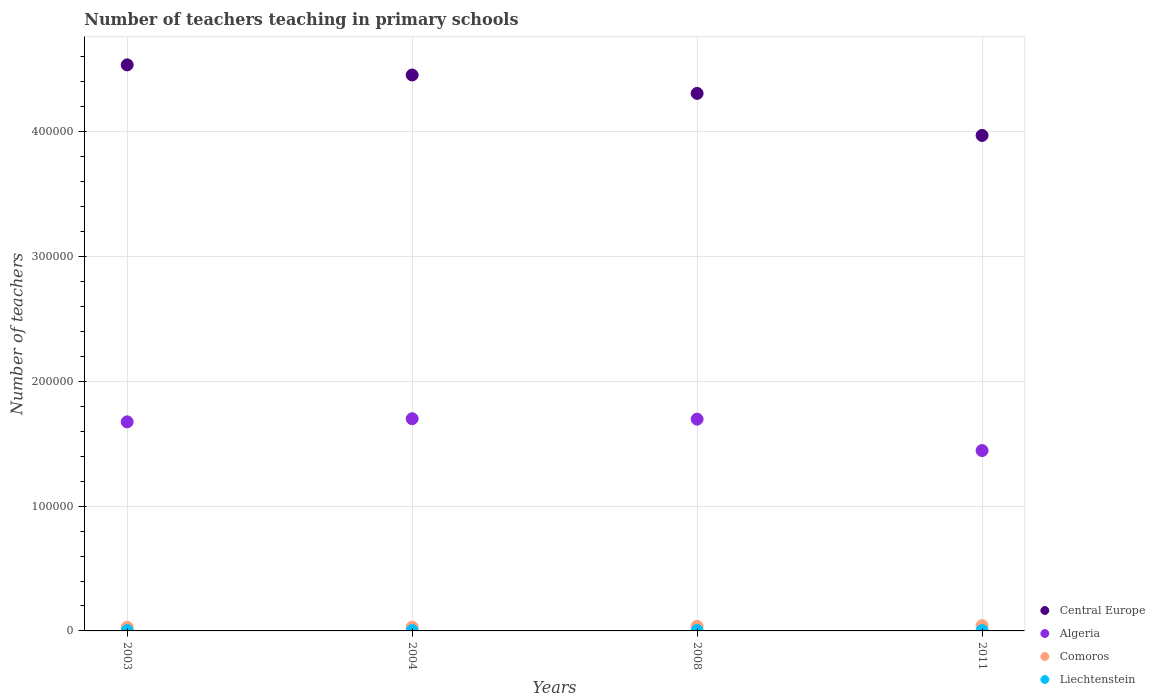How many different coloured dotlines are there?
Your response must be concise. 4. What is the number of teachers teaching in primary schools in Liechtenstein in 2004?
Your answer should be very brief. 260. Across all years, what is the maximum number of teachers teaching in primary schools in Comoros?
Offer a very short reply. 4201. Across all years, what is the minimum number of teachers teaching in primary schools in Algeria?
Your answer should be compact. 1.45e+05. In which year was the number of teachers teaching in primary schools in Algeria maximum?
Your answer should be very brief. 2004. In which year was the number of teachers teaching in primary schools in Liechtenstein minimum?
Offer a very short reply. 2003. What is the total number of teachers teaching in primary schools in Liechtenstein in the graph?
Give a very brief answer. 1091. What is the difference between the number of teachers teaching in primary schools in Algeria in 2008 and that in 2011?
Offer a very short reply. 2.52e+04. What is the difference between the number of teachers teaching in primary schools in Central Europe in 2011 and the number of teachers teaching in primary schools in Comoros in 2003?
Provide a short and direct response. 3.94e+05. What is the average number of teachers teaching in primary schools in Liechtenstein per year?
Offer a terse response. 272.75. In the year 2003, what is the difference between the number of teachers teaching in primary schools in Algeria and number of teachers teaching in primary schools in Comoros?
Your response must be concise. 1.65e+05. What is the ratio of the number of teachers teaching in primary schools in Comoros in 2003 to that in 2008?
Provide a short and direct response. 0.79. Is the number of teachers teaching in primary schools in Liechtenstein in 2003 less than that in 2008?
Give a very brief answer. Yes. Is the difference between the number of teachers teaching in primary schools in Algeria in 2003 and 2008 greater than the difference between the number of teachers teaching in primary schools in Comoros in 2003 and 2008?
Offer a very short reply. No. What is the difference between the highest and the second highest number of teachers teaching in primary schools in Algeria?
Offer a very short reply. 330. What is the difference between the highest and the lowest number of teachers teaching in primary schools in Central Europe?
Your response must be concise. 5.65e+04. Is the sum of the number of teachers teaching in primary schools in Algeria in 2003 and 2004 greater than the maximum number of teachers teaching in primary schools in Central Europe across all years?
Provide a succinct answer. No. Is the number of teachers teaching in primary schools in Central Europe strictly greater than the number of teachers teaching in primary schools in Algeria over the years?
Offer a terse response. Yes. Is the number of teachers teaching in primary schools in Central Europe strictly less than the number of teachers teaching in primary schools in Comoros over the years?
Ensure brevity in your answer.  No. How many legend labels are there?
Your answer should be compact. 4. How are the legend labels stacked?
Make the answer very short. Vertical. What is the title of the graph?
Your answer should be very brief. Number of teachers teaching in primary schools. Does "India" appear as one of the legend labels in the graph?
Make the answer very short. No. What is the label or title of the Y-axis?
Offer a very short reply. Number of teachers. What is the Number of teachers in Central Europe in 2003?
Make the answer very short. 4.54e+05. What is the Number of teachers of Algeria in 2003?
Offer a very short reply. 1.68e+05. What is the Number of teachers of Comoros in 2003?
Your answer should be compact. 2908. What is the Number of teachers of Liechtenstein in 2003?
Provide a succinct answer. 242. What is the Number of teachers in Central Europe in 2004?
Ensure brevity in your answer.  4.45e+05. What is the Number of teachers in Algeria in 2004?
Ensure brevity in your answer.  1.70e+05. What is the Number of teachers in Comoros in 2004?
Ensure brevity in your answer.  2967. What is the Number of teachers in Liechtenstein in 2004?
Keep it short and to the point. 260. What is the Number of teachers in Central Europe in 2008?
Your answer should be very brief. 4.31e+05. What is the Number of teachers in Algeria in 2008?
Your answer should be very brief. 1.70e+05. What is the Number of teachers of Comoros in 2008?
Make the answer very short. 3685. What is the Number of teachers in Liechtenstein in 2008?
Offer a terse response. 332. What is the Number of teachers in Central Europe in 2011?
Provide a short and direct response. 3.97e+05. What is the Number of teachers in Algeria in 2011?
Make the answer very short. 1.45e+05. What is the Number of teachers in Comoros in 2011?
Your response must be concise. 4201. What is the Number of teachers of Liechtenstein in 2011?
Make the answer very short. 257. Across all years, what is the maximum Number of teachers in Central Europe?
Offer a terse response. 4.54e+05. Across all years, what is the maximum Number of teachers in Algeria?
Your response must be concise. 1.70e+05. Across all years, what is the maximum Number of teachers of Comoros?
Your answer should be compact. 4201. Across all years, what is the maximum Number of teachers of Liechtenstein?
Offer a very short reply. 332. Across all years, what is the minimum Number of teachers in Central Europe?
Offer a very short reply. 3.97e+05. Across all years, what is the minimum Number of teachers in Algeria?
Your response must be concise. 1.45e+05. Across all years, what is the minimum Number of teachers of Comoros?
Provide a succinct answer. 2908. Across all years, what is the minimum Number of teachers in Liechtenstein?
Provide a succinct answer. 242. What is the total Number of teachers of Central Europe in the graph?
Make the answer very short. 1.73e+06. What is the total Number of teachers in Algeria in the graph?
Your response must be concise. 6.52e+05. What is the total Number of teachers in Comoros in the graph?
Give a very brief answer. 1.38e+04. What is the total Number of teachers of Liechtenstein in the graph?
Make the answer very short. 1091. What is the difference between the Number of teachers in Central Europe in 2003 and that in 2004?
Provide a short and direct response. 8121.78. What is the difference between the Number of teachers in Algeria in 2003 and that in 2004?
Your response must be concise. -2502. What is the difference between the Number of teachers of Comoros in 2003 and that in 2004?
Ensure brevity in your answer.  -59. What is the difference between the Number of teachers in Central Europe in 2003 and that in 2008?
Your response must be concise. 2.29e+04. What is the difference between the Number of teachers of Algeria in 2003 and that in 2008?
Your response must be concise. -2172. What is the difference between the Number of teachers in Comoros in 2003 and that in 2008?
Your answer should be very brief. -777. What is the difference between the Number of teachers in Liechtenstein in 2003 and that in 2008?
Offer a terse response. -90. What is the difference between the Number of teachers in Central Europe in 2003 and that in 2011?
Your response must be concise. 5.65e+04. What is the difference between the Number of teachers of Algeria in 2003 and that in 2011?
Give a very brief answer. 2.30e+04. What is the difference between the Number of teachers of Comoros in 2003 and that in 2011?
Your response must be concise. -1293. What is the difference between the Number of teachers of Central Europe in 2004 and that in 2008?
Provide a succinct answer. 1.47e+04. What is the difference between the Number of teachers in Algeria in 2004 and that in 2008?
Make the answer very short. 330. What is the difference between the Number of teachers in Comoros in 2004 and that in 2008?
Your answer should be very brief. -718. What is the difference between the Number of teachers in Liechtenstein in 2004 and that in 2008?
Keep it short and to the point. -72. What is the difference between the Number of teachers of Central Europe in 2004 and that in 2011?
Your answer should be very brief. 4.84e+04. What is the difference between the Number of teachers of Algeria in 2004 and that in 2011?
Give a very brief answer. 2.55e+04. What is the difference between the Number of teachers in Comoros in 2004 and that in 2011?
Offer a terse response. -1234. What is the difference between the Number of teachers of Central Europe in 2008 and that in 2011?
Your answer should be compact. 3.37e+04. What is the difference between the Number of teachers of Algeria in 2008 and that in 2011?
Ensure brevity in your answer.  2.52e+04. What is the difference between the Number of teachers of Comoros in 2008 and that in 2011?
Offer a terse response. -516. What is the difference between the Number of teachers in Central Europe in 2003 and the Number of teachers in Algeria in 2004?
Offer a very short reply. 2.84e+05. What is the difference between the Number of teachers of Central Europe in 2003 and the Number of teachers of Comoros in 2004?
Provide a succinct answer. 4.51e+05. What is the difference between the Number of teachers of Central Europe in 2003 and the Number of teachers of Liechtenstein in 2004?
Make the answer very short. 4.53e+05. What is the difference between the Number of teachers of Algeria in 2003 and the Number of teachers of Comoros in 2004?
Provide a short and direct response. 1.65e+05. What is the difference between the Number of teachers in Algeria in 2003 and the Number of teachers in Liechtenstein in 2004?
Ensure brevity in your answer.  1.67e+05. What is the difference between the Number of teachers of Comoros in 2003 and the Number of teachers of Liechtenstein in 2004?
Keep it short and to the point. 2648. What is the difference between the Number of teachers in Central Europe in 2003 and the Number of teachers in Algeria in 2008?
Your response must be concise. 2.84e+05. What is the difference between the Number of teachers of Central Europe in 2003 and the Number of teachers of Comoros in 2008?
Provide a succinct answer. 4.50e+05. What is the difference between the Number of teachers of Central Europe in 2003 and the Number of teachers of Liechtenstein in 2008?
Keep it short and to the point. 4.53e+05. What is the difference between the Number of teachers in Algeria in 2003 and the Number of teachers in Comoros in 2008?
Give a very brief answer. 1.64e+05. What is the difference between the Number of teachers in Algeria in 2003 and the Number of teachers in Liechtenstein in 2008?
Offer a terse response. 1.67e+05. What is the difference between the Number of teachers of Comoros in 2003 and the Number of teachers of Liechtenstein in 2008?
Make the answer very short. 2576. What is the difference between the Number of teachers of Central Europe in 2003 and the Number of teachers of Algeria in 2011?
Make the answer very short. 3.09e+05. What is the difference between the Number of teachers in Central Europe in 2003 and the Number of teachers in Comoros in 2011?
Offer a terse response. 4.49e+05. What is the difference between the Number of teachers of Central Europe in 2003 and the Number of teachers of Liechtenstein in 2011?
Offer a very short reply. 4.53e+05. What is the difference between the Number of teachers of Algeria in 2003 and the Number of teachers of Comoros in 2011?
Ensure brevity in your answer.  1.63e+05. What is the difference between the Number of teachers of Algeria in 2003 and the Number of teachers of Liechtenstein in 2011?
Keep it short and to the point. 1.67e+05. What is the difference between the Number of teachers of Comoros in 2003 and the Number of teachers of Liechtenstein in 2011?
Ensure brevity in your answer.  2651. What is the difference between the Number of teachers in Central Europe in 2004 and the Number of teachers in Algeria in 2008?
Ensure brevity in your answer.  2.76e+05. What is the difference between the Number of teachers in Central Europe in 2004 and the Number of teachers in Comoros in 2008?
Offer a very short reply. 4.42e+05. What is the difference between the Number of teachers in Central Europe in 2004 and the Number of teachers in Liechtenstein in 2008?
Ensure brevity in your answer.  4.45e+05. What is the difference between the Number of teachers in Algeria in 2004 and the Number of teachers in Comoros in 2008?
Your response must be concise. 1.66e+05. What is the difference between the Number of teachers of Algeria in 2004 and the Number of teachers of Liechtenstein in 2008?
Provide a succinct answer. 1.70e+05. What is the difference between the Number of teachers in Comoros in 2004 and the Number of teachers in Liechtenstein in 2008?
Your answer should be very brief. 2635. What is the difference between the Number of teachers in Central Europe in 2004 and the Number of teachers in Algeria in 2011?
Offer a terse response. 3.01e+05. What is the difference between the Number of teachers in Central Europe in 2004 and the Number of teachers in Comoros in 2011?
Your answer should be very brief. 4.41e+05. What is the difference between the Number of teachers in Central Europe in 2004 and the Number of teachers in Liechtenstein in 2011?
Your answer should be compact. 4.45e+05. What is the difference between the Number of teachers of Algeria in 2004 and the Number of teachers of Comoros in 2011?
Ensure brevity in your answer.  1.66e+05. What is the difference between the Number of teachers of Algeria in 2004 and the Number of teachers of Liechtenstein in 2011?
Your answer should be very brief. 1.70e+05. What is the difference between the Number of teachers of Comoros in 2004 and the Number of teachers of Liechtenstein in 2011?
Offer a terse response. 2710. What is the difference between the Number of teachers in Central Europe in 2008 and the Number of teachers in Algeria in 2011?
Ensure brevity in your answer.  2.86e+05. What is the difference between the Number of teachers in Central Europe in 2008 and the Number of teachers in Comoros in 2011?
Your answer should be very brief. 4.27e+05. What is the difference between the Number of teachers of Central Europe in 2008 and the Number of teachers of Liechtenstein in 2011?
Provide a succinct answer. 4.30e+05. What is the difference between the Number of teachers of Algeria in 2008 and the Number of teachers of Comoros in 2011?
Offer a terse response. 1.66e+05. What is the difference between the Number of teachers of Algeria in 2008 and the Number of teachers of Liechtenstein in 2011?
Offer a terse response. 1.69e+05. What is the difference between the Number of teachers in Comoros in 2008 and the Number of teachers in Liechtenstein in 2011?
Offer a very short reply. 3428. What is the average Number of teachers in Central Europe per year?
Keep it short and to the point. 4.32e+05. What is the average Number of teachers of Algeria per year?
Keep it short and to the point. 1.63e+05. What is the average Number of teachers of Comoros per year?
Give a very brief answer. 3440.25. What is the average Number of teachers in Liechtenstein per year?
Make the answer very short. 272.75. In the year 2003, what is the difference between the Number of teachers in Central Europe and Number of teachers in Algeria?
Keep it short and to the point. 2.86e+05. In the year 2003, what is the difference between the Number of teachers of Central Europe and Number of teachers of Comoros?
Keep it short and to the point. 4.51e+05. In the year 2003, what is the difference between the Number of teachers in Central Europe and Number of teachers in Liechtenstein?
Make the answer very short. 4.53e+05. In the year 2003, what is the difference between the Number of teachers in Algeria and Number of teachers in Comoros?
Offer a terse response. 1.65e+05. In the year 2003, what is the difference between the Number of teachers of Algeria and Number of teachers of Liechtenstein?
Your answer should be compact. 1.67e+05. In the year 2003, what is the difference between the Number of teachers in Comoros and Number of teachers in Liechtenstein?
Keep it short and to the point. 2666. In the year 2004, what is the difference between the Number of teachers in Central Europe and Number of teachers in Algeria?
Keep it short and to the point. 2.75e+05. In the year 2004, what is the difference between the Number of teachers of Central Europe and Number of teachers of Comoros?
Provide a succinct answer. 4.43e+05. In the year 2004, what is the difference between the Number of teachers in Central Europe and Number of teachers in Liechtenstein?
Offer a terse response. 4.45e+05. In the year 2004, what is the difference between the Number of teachers of Algeria and Number of teachers of Comoros?
Keep it short and to the point. 1.67e+05. In the year 2004, what is the difference between the Number of teachers in Algeria and Number of teachers in Liechtenstein?
Offer a terse response. 1.70e+05. In the year 2004, what is the difference between the Number of teachers of Comoros and Number of teachers of Liechtenstein?
Your response must be concise. 2707. In the year 2008, what is the difference between the Number of teachers of Central Europe and Number of teachers of Algeria?
Your response must be concise. 2.61e+05. In the year 2008, what is the difference between the Number of teachers of Central Europe and Number of teachers of Comoros?
Provide a succinct answer. 4.27e+05. In the year 2008, what is the difference between the Number of teachers in Central Europe and Number of teachers in Liechtenstein?
Provide a succinct answer. 4.30e+05. In the year 2008, what is the difference between the Number of teachers in Algeria and Number of teachers in Comoros?
Keep it short and to the point. 1.66e+05. In the year 2008, what is the difference between the Number of teachers in Algeria and Number of teachers in Liechtenstein?
Provide a short and direct response. 1.69e+05. In the year 2008, what is the difference between the Number of teachers in Comoros and Number of teachers in Liechtenstein?
Your answer should be very brief. 3353. In the year 2011, what is the difference between the Number of teachers of Central Europe and Number of teachers of Algeria?
Make the answer very short. 2.53e+05. In the year 2011, what is the difference between the Number of teachers of Central Europe and Number of teachers of Comoros?
Offer a terse response. 3.93e+05. In the year 2011, what is the difference between the Number of teachers in Central Europe and Number of teachers in Liechtenstein?
Ensure brevity in your answer.  3.97e+05. In the year 2011, what is the difference between the Number of teachers of Algeria and Number of teachers of Comoros?
Your answer should be very brief. 1.40e+05. In the year 2011, what is the difference between the Number of teachers in Algeria and Number of teachers in Liechtenstein?
Your answer should be very brief. 1.44e+05. In the year 2011, what is the difference between the Number of teachers in Comoros and Number of teachers in Liechtenstein?
Keep it short and to the point. 3944. What is the ratio of the Number of teachers of Central Europe in 2003 to that in 2004?
Provide a succinct answer. 1.02. What is the ratio of the Number of teachers of Comoros in 2003 to that in 2004?
Your answer should be compact. 0.98. What is the ratio of the Number of teachers of Liechtenstein in 2003 to that in 2004?
Offer a terse response. 0.93. What is the ratio of the Number of teachers in Central Europe in 2003 to that in 2008?
Provide a short and direct response. 1.05. What is the ratio of the Number of teachers in Algeria in 2003 to that in 2008?
Your answer should be very brief. 0.99. What is the ratio of the Number of teachers of Comoros in 2003 to that in 2008?
Make the answer very short. 0.79. What is the ratio of the Number of teachers in Liechtenstein in 2003 to that in 2008?
Provide a succinct answer. 0.73. What is the ratio of the Number of teachers in Central Europe in 2003 to that in 2011?
Ensure brevity in your answer.  1.14. What is the ratio of the Number of teachers in Algeria in 2003 to that in 2011?
Offer a very short reply. 1.16. What is the ratio of the Number of teachers in Comoros in 2003 to that in 2011?
Make the answer very short. 0.69. What is the ratio of the Number of teachers of Liechtenstein in 2003 to that in 2011?
Ensure brevity in your answer.  0.94. What is the ratio of the Number of teachers in Central Europe in 2004 to that in 2008?
Offer a very short reply. 1.03. What is the ratio of the Number of teachers in Comoros in 2004 to that in 2008?
Provide a succinct answer. 0.81. What is the ratio of the Number of teachers of Liechtenstein in 2004 to that in 2008?
Keep it short and to the point. 0.78. What is the ratio of the Number of teachers of Central Europe in 2004 to that in 2011?
Your response must be concise. 1.12. What is the ratio of the Number of teachers in Algeria in 2004 to that in 2011?
Give a very brief answer. 1.18. What is the ratio of the Number of teachers of Comoros in 2004 to that in 2011?
Provide a short and direct response. 0.71. What is the ratio of the Number of teachers in Liechtenstein in 2004 to that in 2011?
Keep it short and to the point. 1.01. What is the ratio of the Number of teachers of Central Europe in 2008 to that in 2011?
Offer a terse response. 1.08. What is the ratio of the Number of teachers in Algeria in 2008 to that in 2011?
Provide a succinct answer. 1.17. What is the ratio of the Number of teachers of Comoros in 2008 to that in 2011?
Give a very brief answer. 0.88. What is the ratio of the Number of teachers of Liechtenstein in 2008 to that in 2011?
Your response must be concise. 1.29. What is the difference between the highest and the second highest Number of teachers in Central Europe?
Give a very brief answer. 8121.78. What is the difference between the highest and the second highest Number of teachers in Algeria?
Provide a succinct answer. 330. What is the difference between the highest and the second highest Number of teachers of Comoros?
Provide a short and direct response. 516. What is the difference between the highest and the lowest Number of teachers in Central Europe?
Make the answer very short. 5.65e+04. What is the difference between the highest and the lowest Number of teachers of Algeria?
Give a very brief answer. 2.55e+04. What is the difference between the highest and the lowest Number of teachers of Comoros?
Your answer should be very brief. 1293. What is the difference between the highest and the lowest Number of teachers of Liechtenstein?
Provide a succinct answer. 90. 